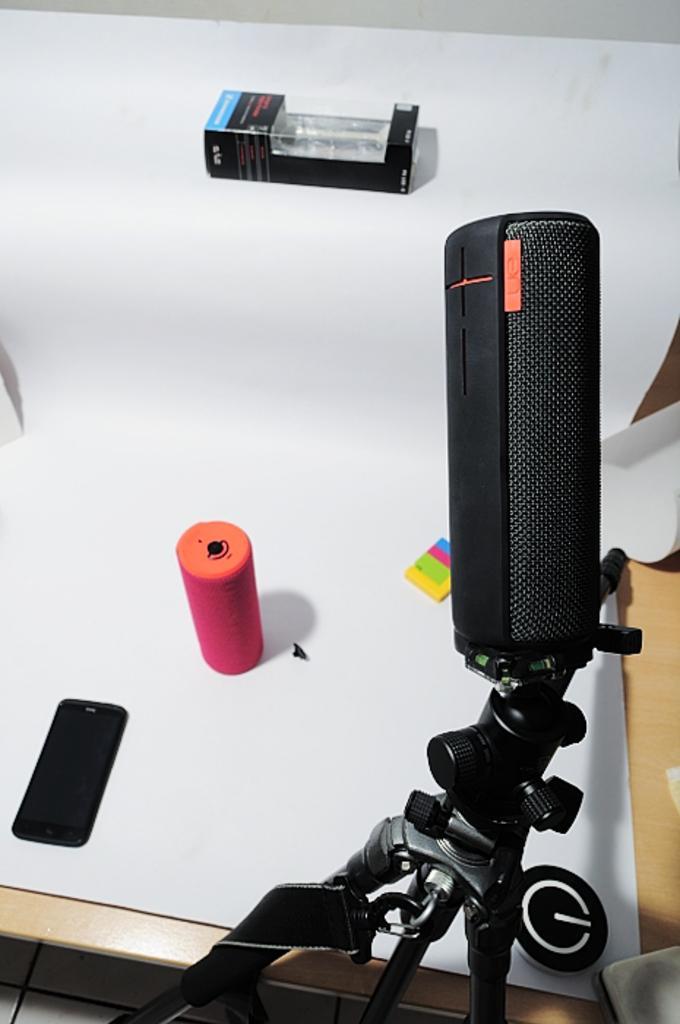Could you give a brief overview of what you see in this image? On the right side of the image we can see a microphone, and we can find a mobile, box and other things on the table. 